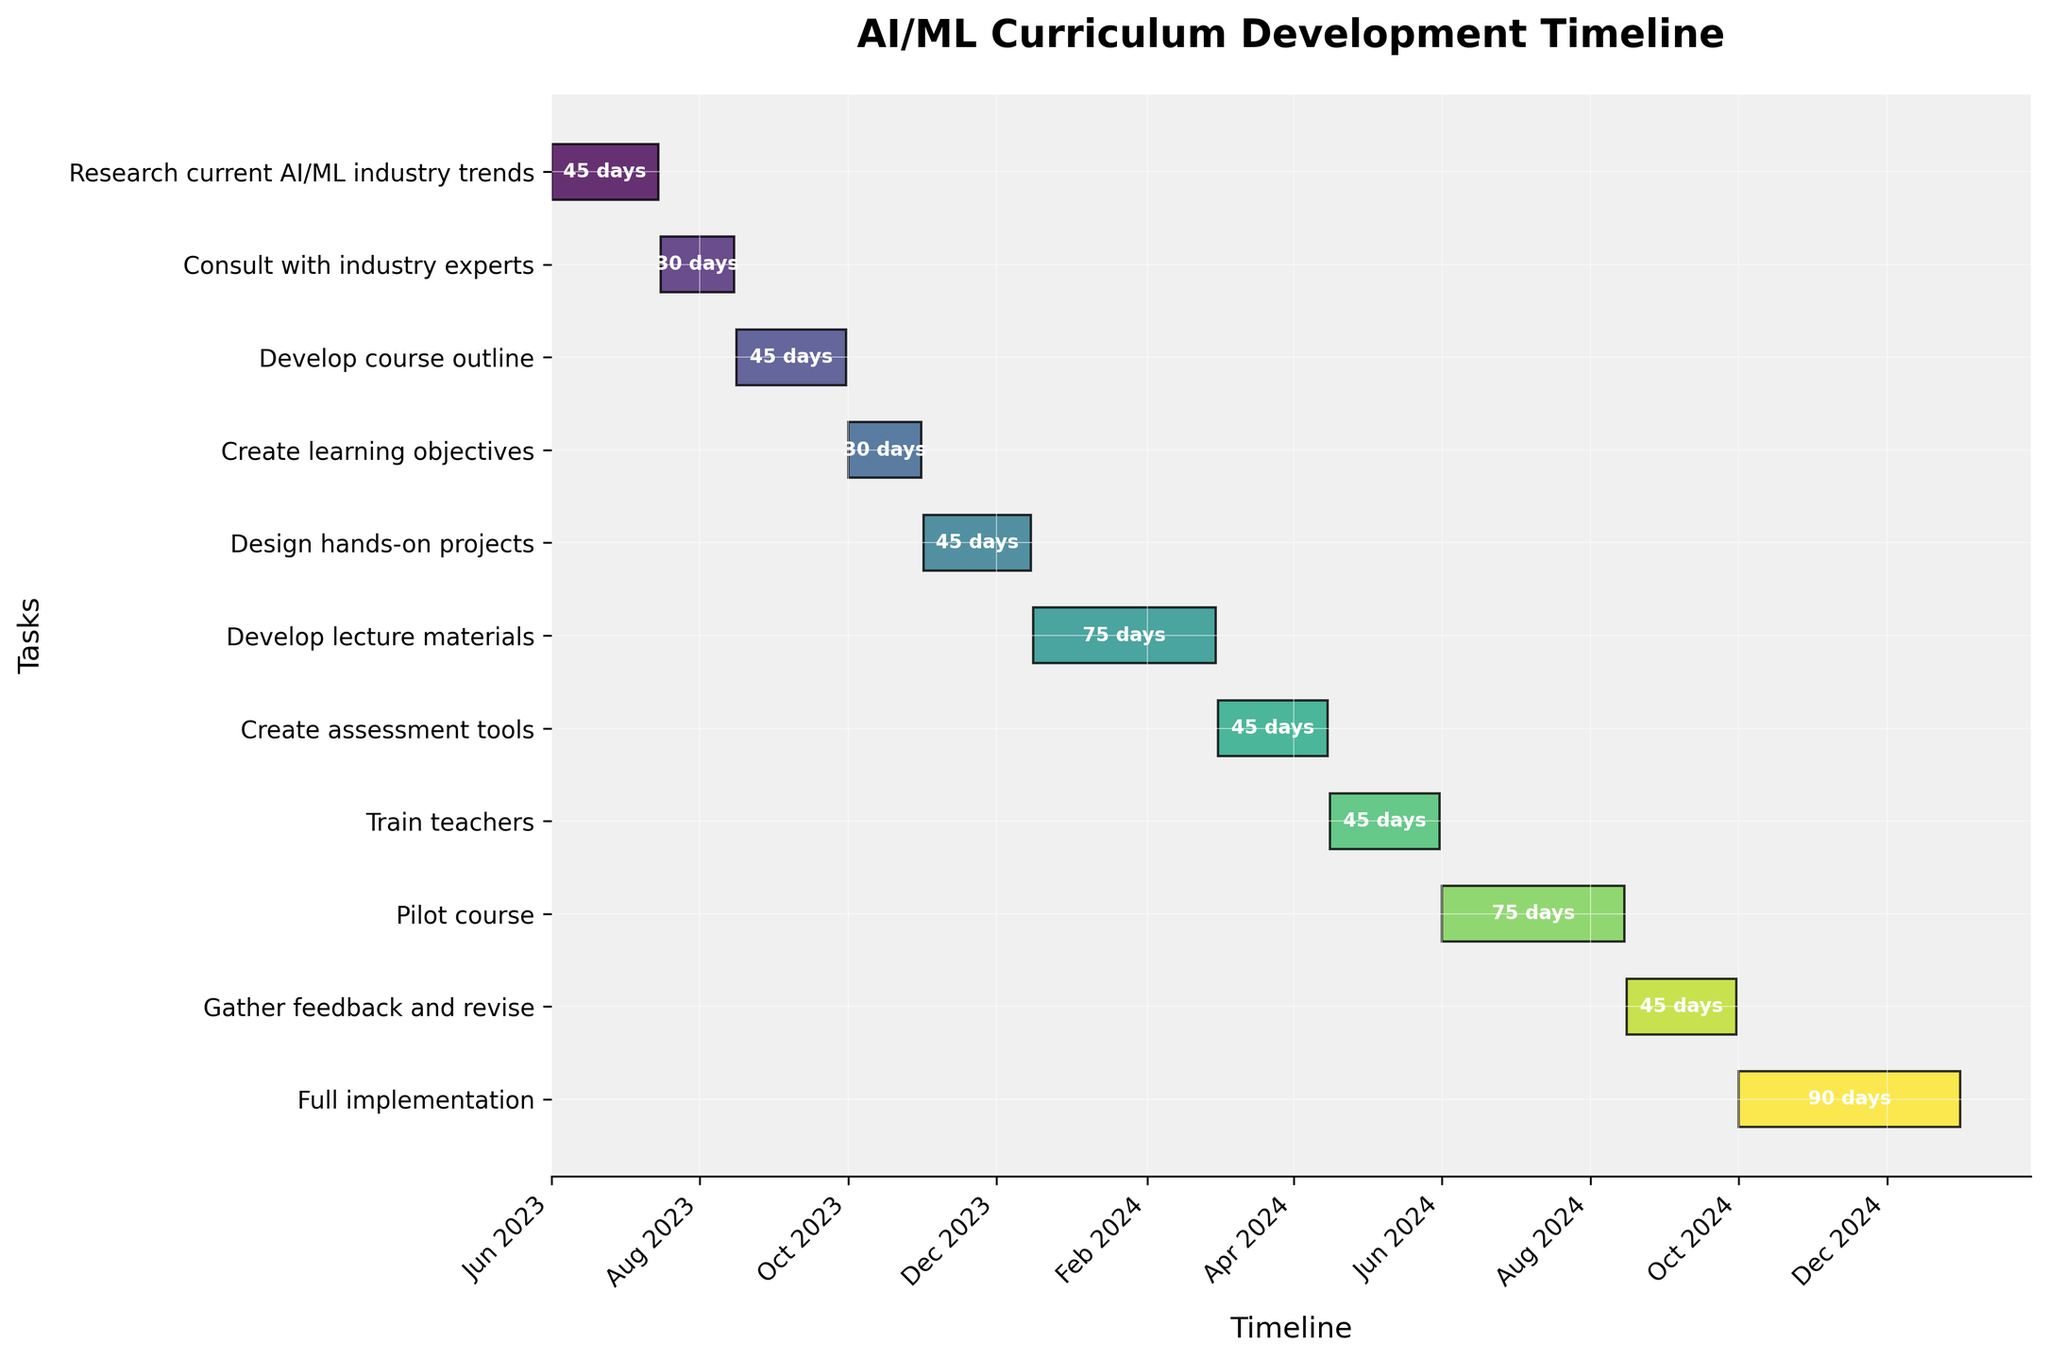What is the duration of the 'Develop course outline' task? The figure shows the duration of each task, with 'Develop course outline' clearly labeled. The duration for this task is 45 days, as noted in the figure.
Answer: 45 days Which task starts immediately after 'Consult with industry experts'? The figure is organized chronologically, and the next task after 'Consult with industry experts' is 'Develop course outline', which starts on August 16, 2023.
Answer: Develop course outline How long does the 'Pilot course' task take compared to the 'Train teachers' task? 'Pilot course' is 75 days long and 'Train teachers' is 45 days long, so 'Pilot course' lasts 30 days longer than 'Train teachers'.
Answer: 30 days longer What are the start and end dates for the 'Full implementation' task? The figure lists the start and end dates for 'Full implementation' as October 1, 2024, to December 31, 2024.
Answer: October 1, 2024, to December 31, 2024 Which tasks have a duration greater than 60 days? Tasks with a duration greater than 60 days are 'Develop lecture materials' (75 days) and 'Pilot course' (75 days), and 'Full implementation' (90 days).
Answer: Develop lecture materials, Pilot course, Full implementation How much time is spent on preparing content ('Develop course outline', 'Design hands-on projects', 'Develop lecture materials', 'Create assessment tools') before 'Train teachers' begins? Summing up the durations: 'Develop course outline' (45 days) + 'Design hands-on projects' (45 days) + 'Develop lecture materials' (75 days) + 'Create assessment tools' (45 days) equals 210 days.
Answer: 210 days What task immediately precedes 'Gather feedback and revise'? From the timeline, 'Pilot course' directly precedes 'Gather feedback and revise'.
Answer: Pilot course How many tasks are scheduled to start in the year 2024? By inspecting the start dates, the tasks starting in 2024 are 'Develop lecture materials', 'Create assessment tools', 'Train teachers', 'Pilot course', 'Gather feedback and revise', and 'Full implementation', totaling 6 tasks.
Answer: 6 tasks Which task has the shortest duration and how long is it? 'Consult with industry experts' and 'Create learning objectives' are the shortest tasks, each lasting 30 days.
Answer: Consult with industry experts and Create learning objectives, 30 days 